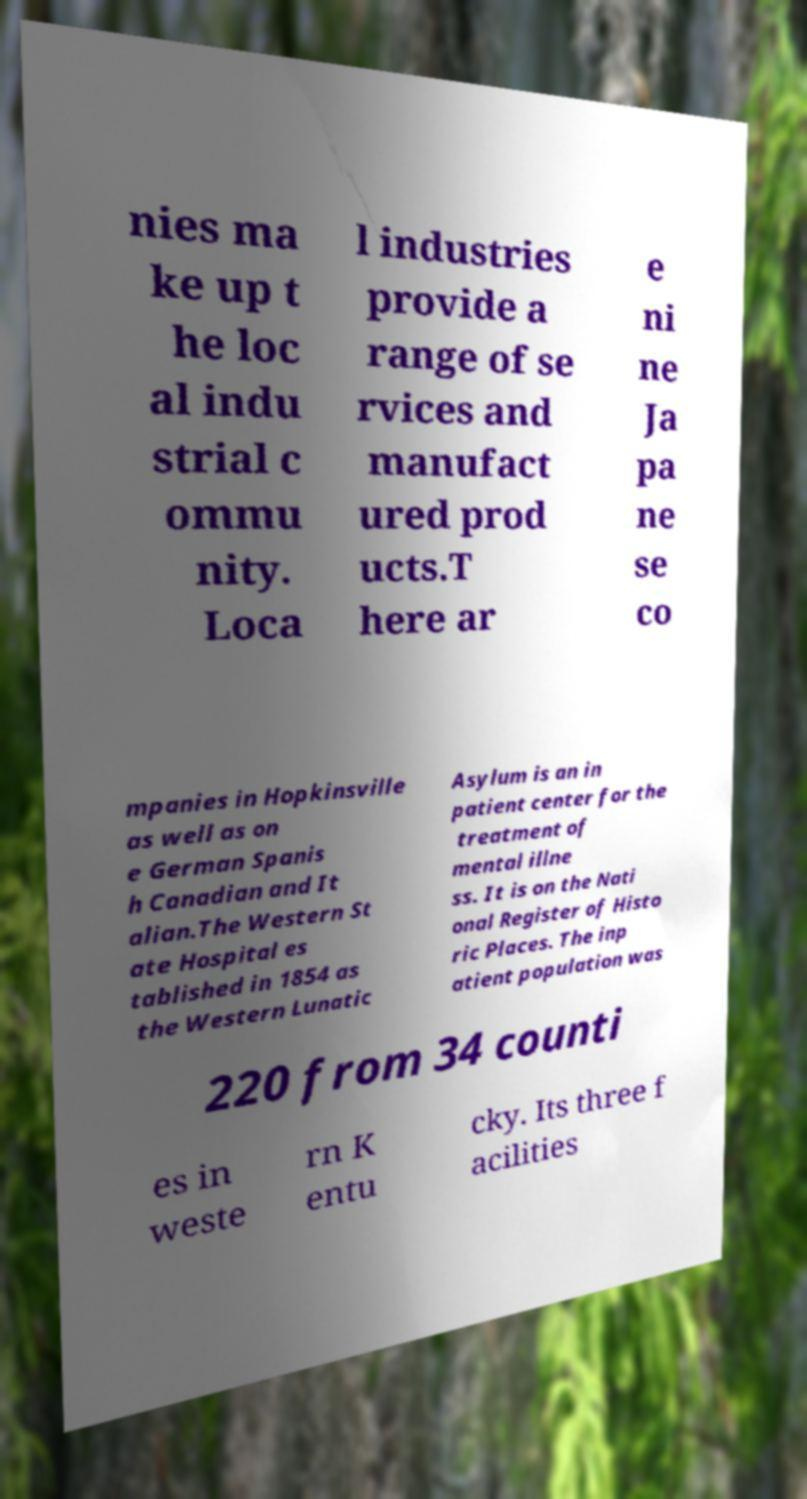Can you accurately transcribe the text from the provided image for me? nies ma ke up t he loc al indu strial c ommu nity. Loca l industries provide a range of se rvices and manufact ured prod ucts.T here ar e ni ne Ja pa ne se co mpanies in Hopkinsville as well as on e German Spanis h Canadian and It alian.The Western St ate Hospital es tablished in 1854 as the Western Lunatic Asylum is an in patient center for the treatment of mental illne ss. It is on the Nati onal Register of Histo ric Places. The inp atient population was 220 from 34 counti es in weste rn K entu cky. Its three f acilities 